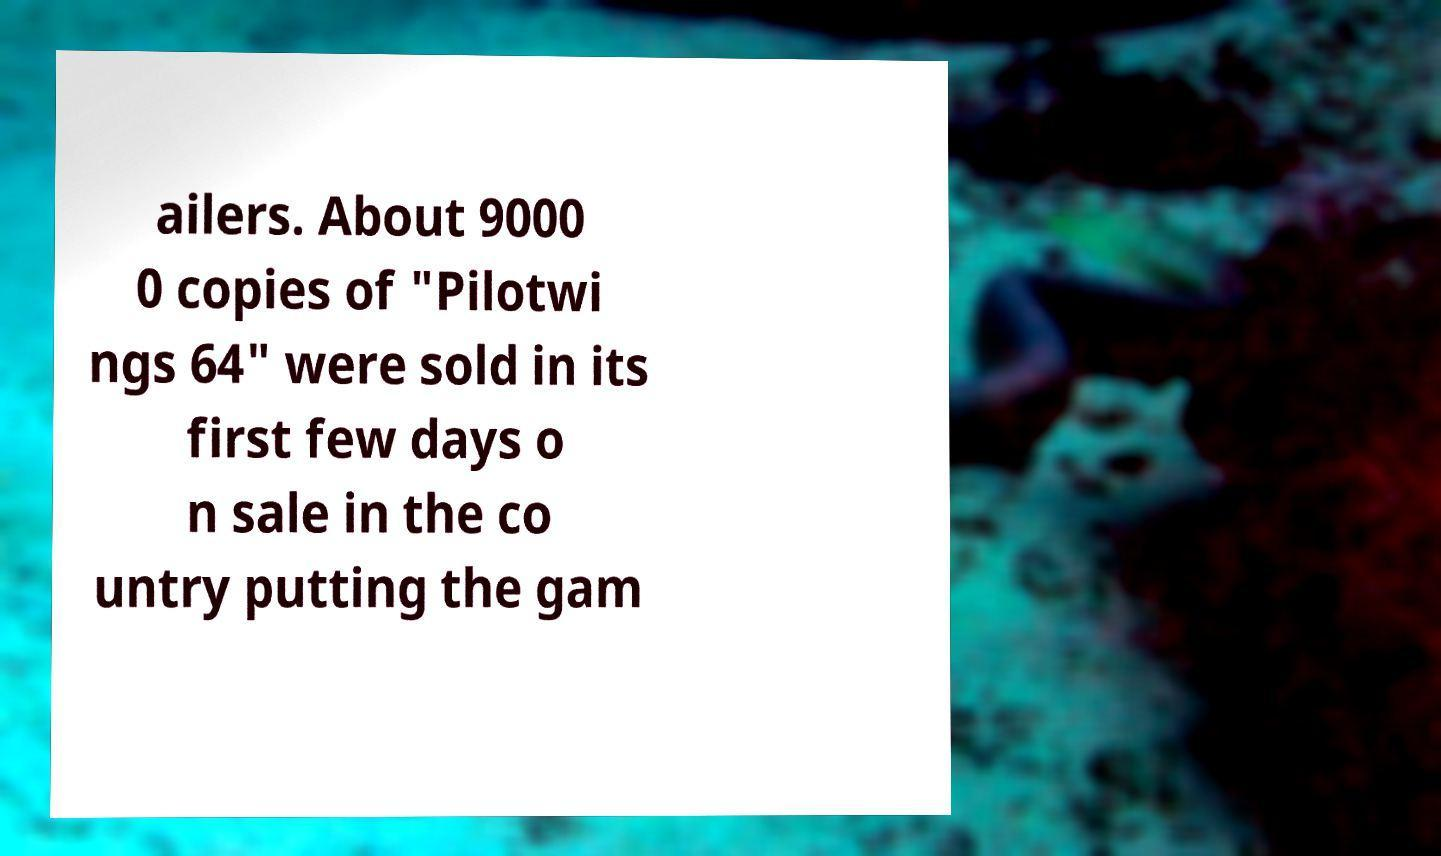For documentation purposes, I need the text within this image transcribed. Could you provide that? ailers. About 9000 0 copies of "Pilotwi ngs 64" were sold in its first few days o n sale in the co untry putting the gam 